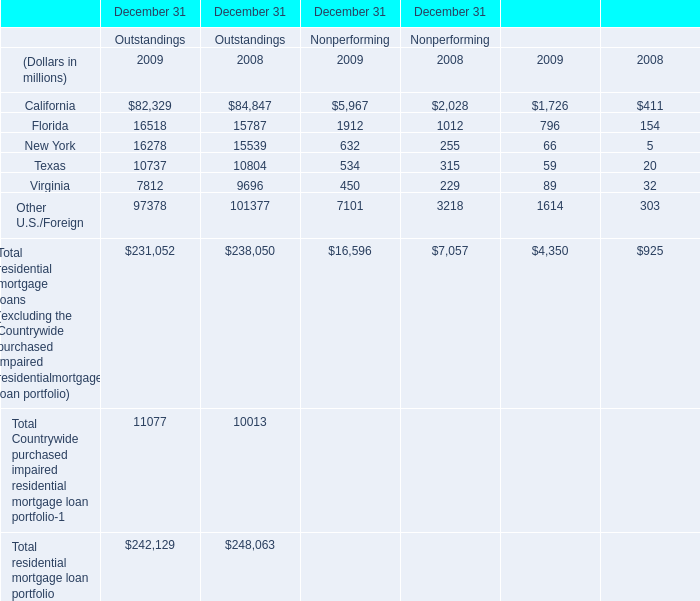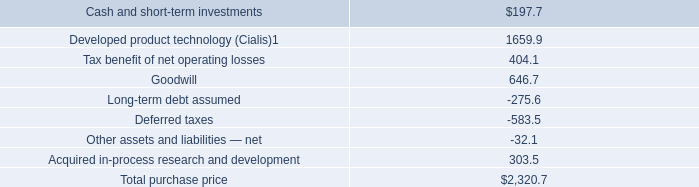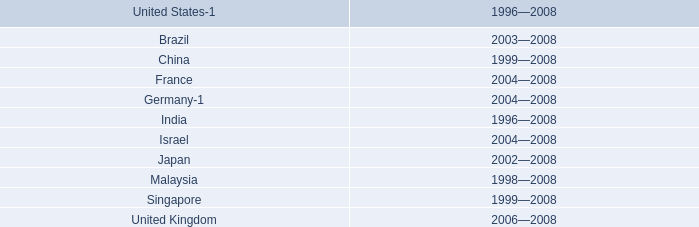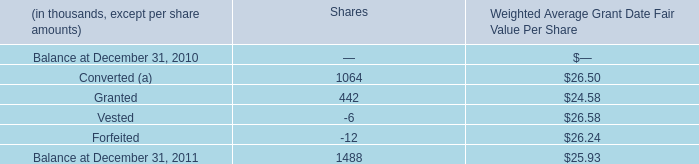at january 29 , 2007 what was the percent of the estimated fair value of the goodwill to the total purchase price 
Computations: (646.7 / 2320.7)
Answer: 0.27867. 